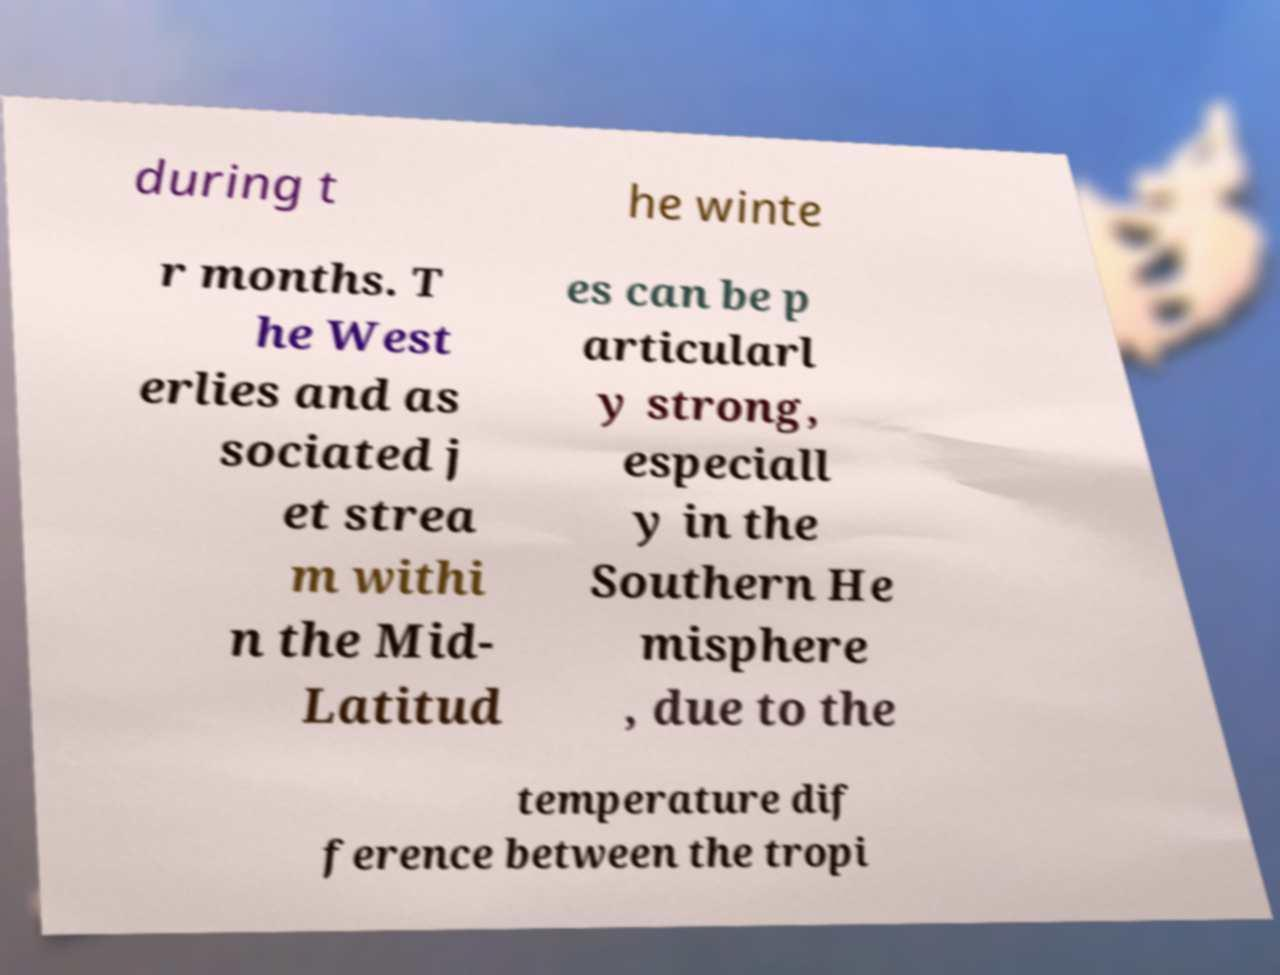What messages or text are displayed in this image? I need them in a readable, typed format. during t he winte r months. T he West erlies and as sociated j et strea m withi n the Mid- Latitud es can be p articularl y strong, especiall y in the Southern He misphere , due to the temperature dif ference between the tropi 